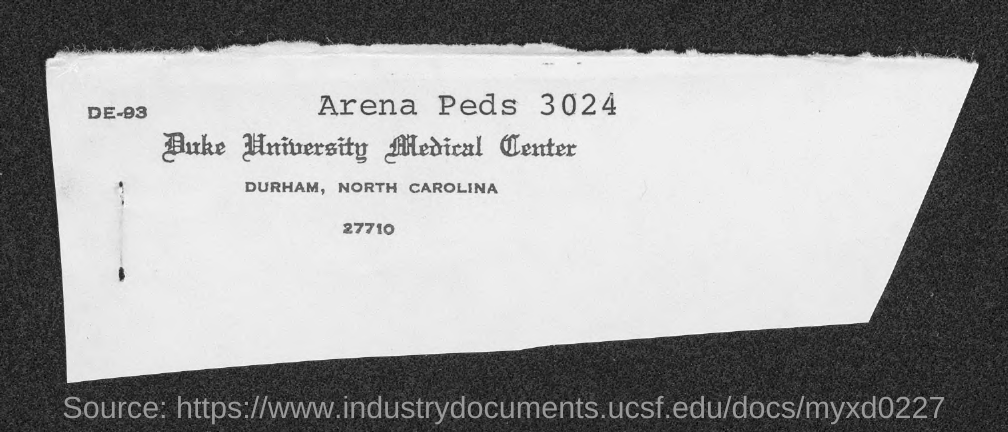What is the city name, in which duke university medical center is at?
Offer a terse response. Durham. 